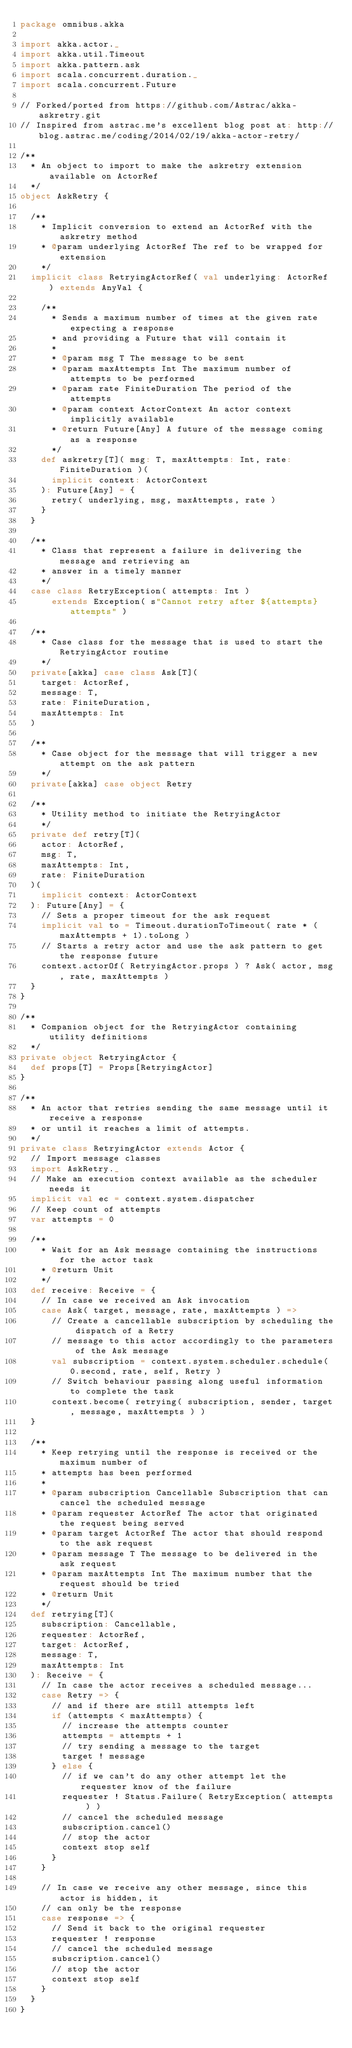Convert code to text. <code><loc_0><loc_0><loc_500><loc_500><_Scala_>package omnibus.akka

import akka.actor._
import akka.util.Timeout
import akka.pattern.ask
import scala.concurrent.duration._
import scala.concurrent.Future

// Forked/ported from https://github.com/Astrac/akka-askretry.git
// Inspired from astrac.me's excellent blog post at: http://blog.astrac.me/coding/2014/02/19/akka-actor-retry/

/**
  * An object to import to make the askretry extension available on ActorRef
  */
object AskRetry {

  /**
    * Implicit conversion to extend an ActorRef with the askretry method
    * @param underlying ActorRef The ref to be wrapped for extension
    */
  implicit class RetryingActorRef( val underlying: ActorRef ) extends AnyVal {

    /**
      * Sends a maximum number of times at the given rate expecting a response
      * and providing a Future that will contain it
      *
      * @param msg T The message to be sent
      * @param maxAttempts Int The maximum number of attempts to be performed
      * @param rate FiniteDuration The period of the attempts
      * @param context ActorContext An actor context implicitly available
      * @return Future[Any] A future of the message coming as a response
      */
    def askretry[T]( msg: T, maxAttempts: Int, rate: FiniteDuration )(
      implicit context: ActorContext
    ): Future[Any] = {
      retry( underlying, msg, maxAttempts, rate )
    }
  }

  /**
    * Class that represent a failure in delivering the message and retrieving an
    * answer in a timely manner
    */
  case class RetryException( attempts: Int )
      extends Exception( s"Cannot retry after ${attempts} attempts" )

  /**
    * Case class for the message that is used to start the RetryingActor routine
    */
  private[akka] case class Ask[T](
    target: ActorRef,
    message: T,
    rate: FiniteDuration,
    maxAttempts: Int
  )

  /**
    * Case object for the message that will trigger a new attempt on the ask pattern
    */
  private[akka] case object Retry

  /**
    * Utility method to initiate the RetryingActor
    */
  private def retry[T](
    actor: ActorRef,
    msg: T,
    maxAttempts: Int,
    rate: FiniteDuration
  )(
    implicit context: ActorContext
  ): Future[Any] = {
    // Sets a proper timeout for the ask request
    implicit val to = Timeout.durationToTimeout( rate * (maxAttempts + 1).toLong )
    // Starts a retry actor and use the ask pattern to get the response future
    context.actorOf( RetryingActor.props ) ? Ask( actor, msg, rate, maxAttempts )
  }
}

/**
  * Companion object for the RetryingActor containing utility definitions
  */
private object RetryingActor {
  def props[T] = Props[RetryingActor]
}

/**
  * An actor that retries sending the same message until it receive a response
  * or until it reaches a limit of attempts.
  */
private class RetryingActor extends Actor {
  // Import message classes
  import AskRetry._
  // Make an execution context available as the scheduler needs it
  implicit val ec = context.system.dispatcher
  // Keep count of attempts
  var attempts = 0

  /**
    * Wait for an Ask message containing the instructions for the actor task
    * @return Unit
    */
  def receive: Receive = {
    // In case we received an Ask invocation
    case Ask( target, message, rate, maxAttempts ) =>
      // Create a cancellable subscription by scheduling the dispatch of a Retry
      // message to this actor accordingly to the parameters of the Ask message
      val subscription = context.system.scheduler.schedule( 0.second, rate, self, Retry )
      // Switch behaviour passing along useful information to complete the task
      context.become( retrying( subscription, sender, target, message, maxAttempts ) )
  }

  /**
    * Keep retrying until the response is received or the maximum number of
    * attempts has been performed
    *
    * @param subscription Cancellable Subscription that can cancel the scheduled message
    * @param requester ActorRef The actor that originated the request being served
    * @param target ActorRef The actor that should respond to the ask request
    * @param message T The message to be delivered in the ask request
    * @param maxAttempts Int The maximum number that the request should be tried
    * @return Unit
    */
  def retrying[T](
    subscription: Cancellable,
    requester: ActorRef,
    target: ActorRef,
    message: T,
    maxAttempts: Int
  ): Receive = {
    // In case the actor receives a scheduled message...
    case Retry => {
      // and if there are still attempts left
      if (attempts < maxAttempts) {
        // increase the attempts counter
        attempts = attempts + 1
        // try sending a message to the target
        target ! message
      } else {
        // if we can't do any other attempt let the requester know of the failure
        requester ! Status.Failure( RetryException( attempts ) )
        // cancel the scheduled message
        subscription.cancel()
        // stop the actor
        context stop self
      }
    }

    // In case we receive any other message, since this actor is hidden, it
    // can only be the response
    case response => {
      // Send it back to the original requester
      requester ! response
      // cancel the scheduled message
      subscription.cancel()
      // stop the actor
      context stop self
    }
  }
}
</code> 